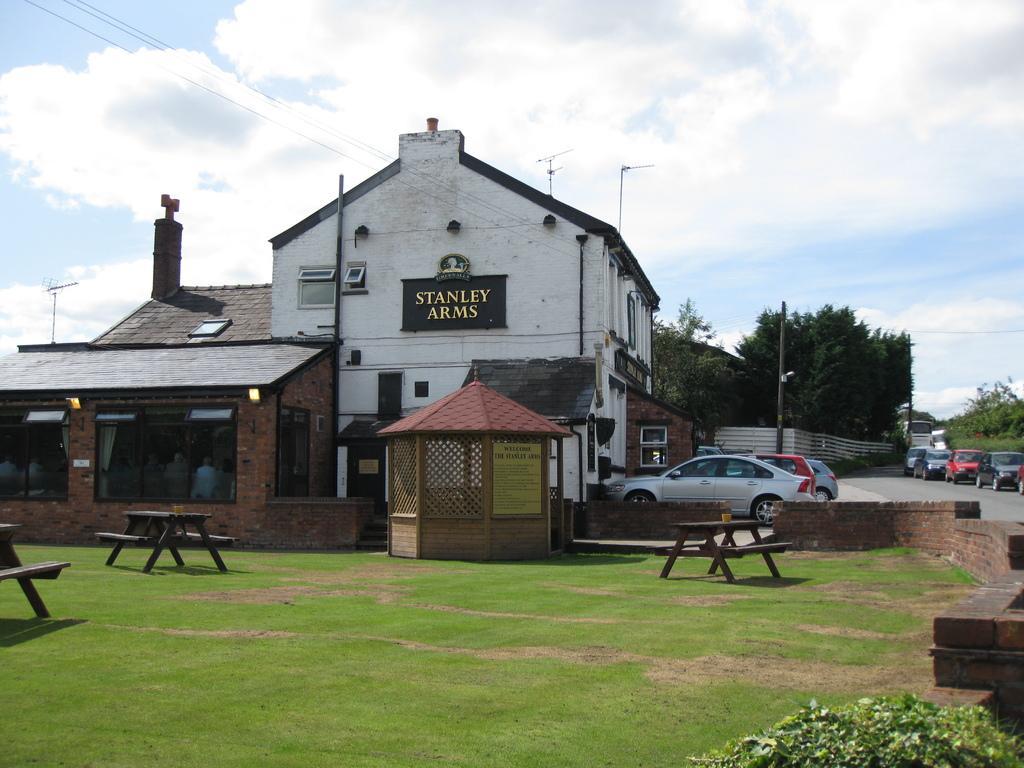How would you summarize this image in a sentence or two? In this picture i can see building, hut and church. On the right there are many cars which are parked near to the building and plants. In the background i can see many trees. On the left i can see wooden tables and benches. At the bottom i can see green grass. At the top i can see sky and clouds. In the top left corner there are electric wires. Beside the buildings i can see the street light and electric poles. 